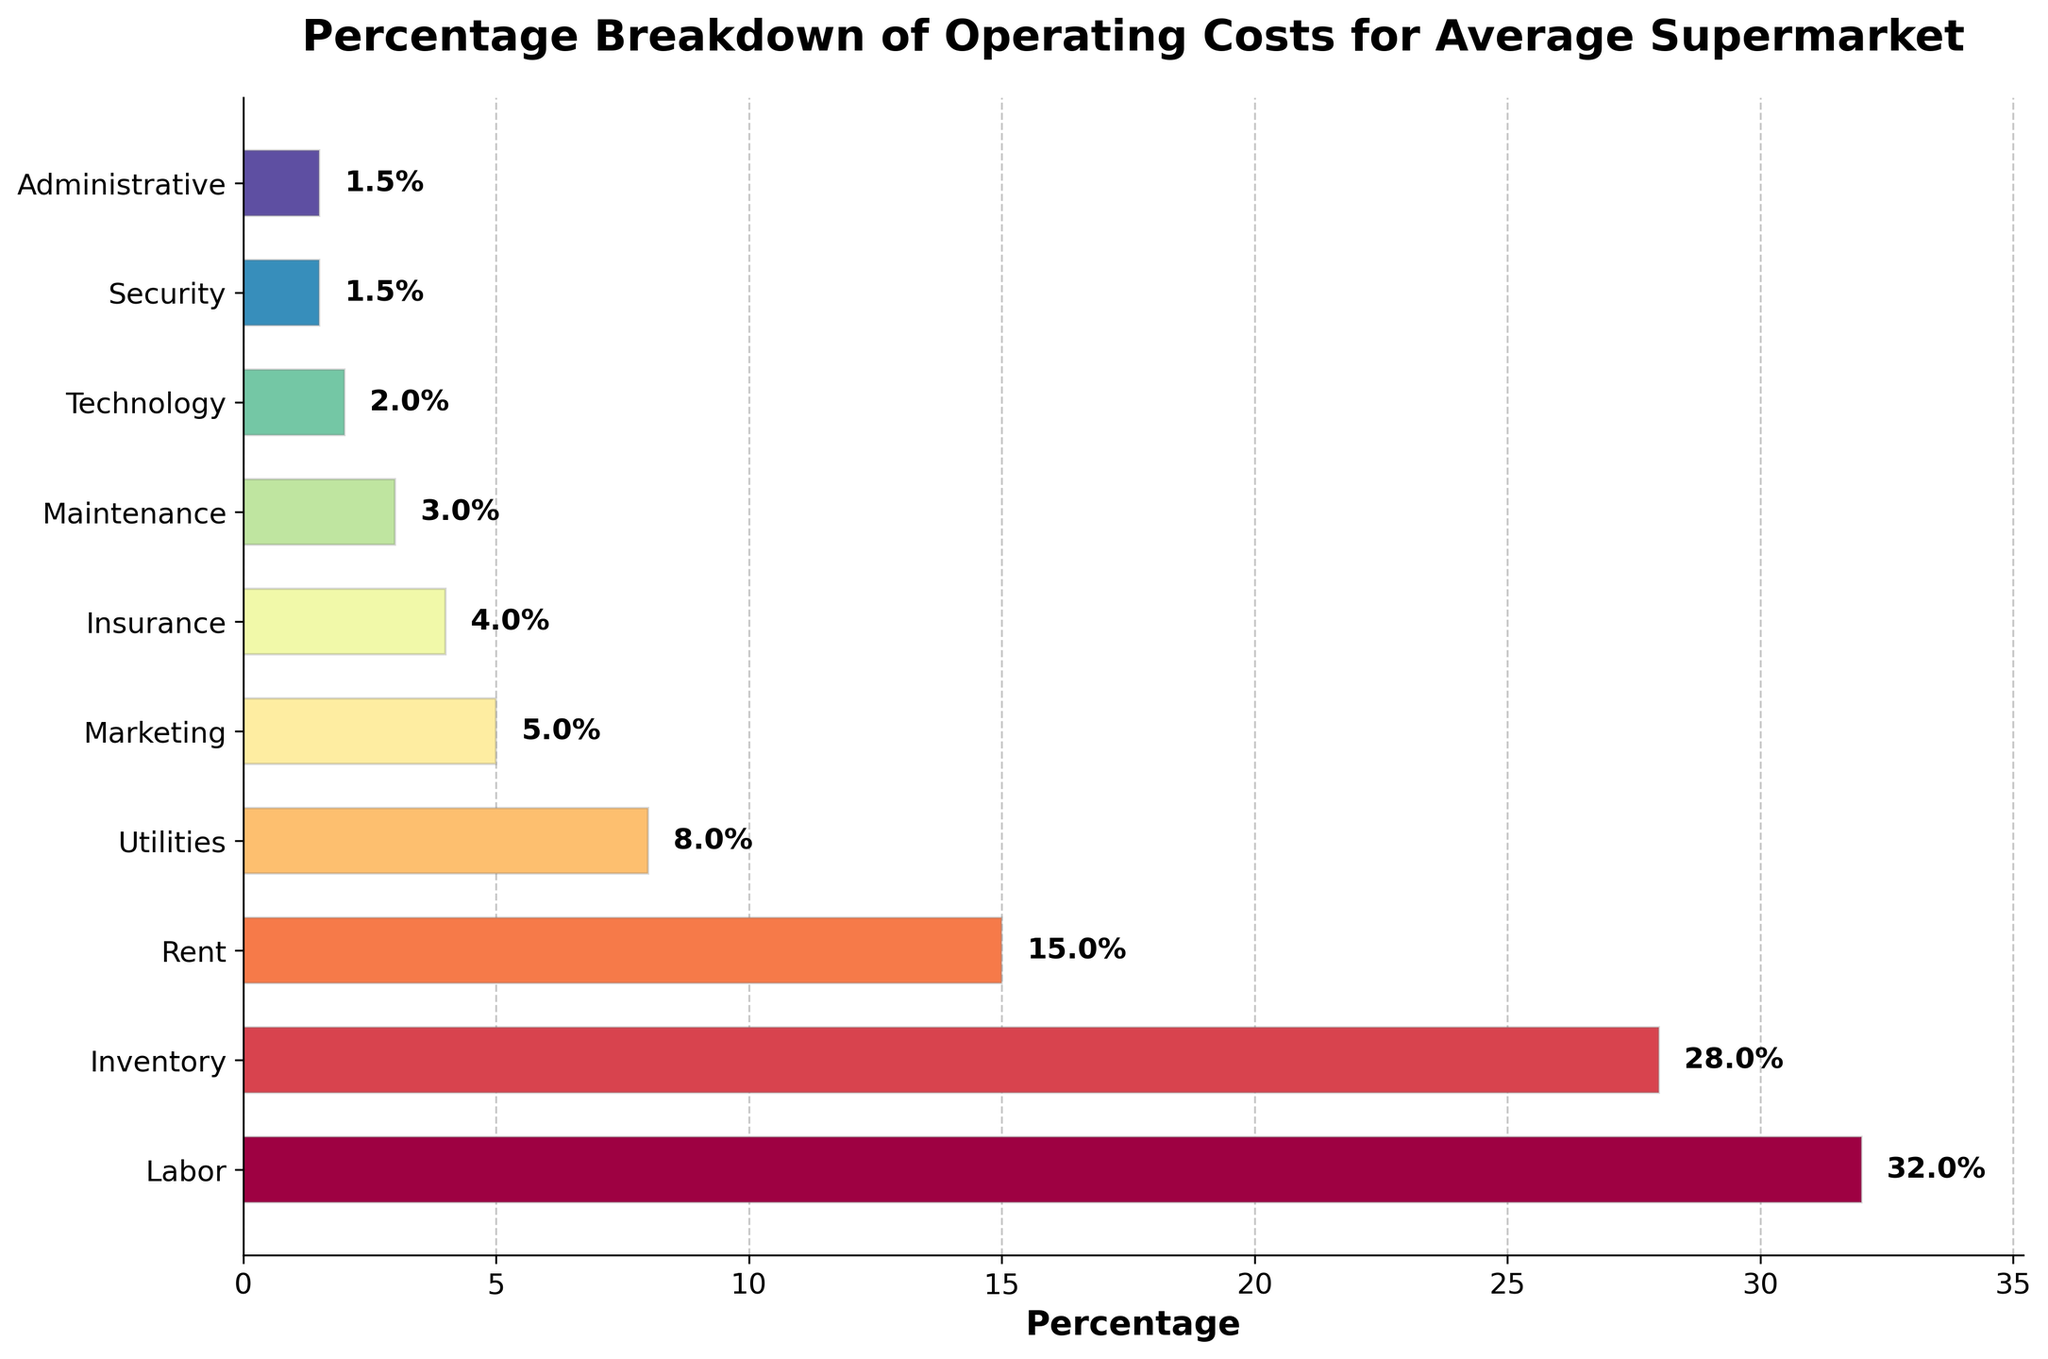What is the largest percentage cost category? The largest percentage cost category has the longest bar in the horizontal bar chart. By looking at the figure, the "Labor" bar is the longest.
Answer: Labor How much more is spent on labor compared to rent? Locate the bars for "Labor" and "Rent." The percentage for "Labor" is 32%, and for "Rent" it is 15%. Subtract Rent from Labor to find the difference: 32% - 15% = 17%.
Answer: 17% Which category has the smallest percentage? The category with the smallest bar will have the smallest percentage. The "Security" and "Administrative" categories both have the smallest percentage, 1.5%.
Answer: Security and Administrative What is the combined percentage of Inventory and Marketing costs? Find the bars for "Inventory" and "Marketing." The percentage for Inventory is 28% and for Marketing is 5%. Add these two percentages together: 28% + 5% = 33%.
Answer: 33% How does the percentage of Maintenance compare to Technology? Identify the bars for "Maintenance" and "Technology." Maintenance is 3%, and Technology is 2%. Maintenance is 1% higher than Technology.
Answer: Maintenance is 1% higher If the total operating costs for an average supermarket are $1,000,000, how much of this is spent on Utilities? Utilities make up 8% of the total operating costs. To find the dollar amount, calculate 8% of $1,000,000: (8 / 100) * $1,000,000 = $80,000.
Answer: $80,000 What is the sum of all percentages excluding the three smallest categories? The three smallest categories are Security (1.5%), Administrative (1.5%), and Technology (2%). Add their percentages: 1.5% + 1.5% + 2% = 5%. Subtract this sum from 100%: 100% - 5% = 95%.
Answer: 95% Which categories contribute more than 20% to the overall operating costs? Categories with bar lengths representing more than 20% are Labor (32%) and Inventory (28%).
Answer: Labor and Inventory What percentage of costs is attributed to non-operational categories like Marketing, Insurance, and Security? Sum the percentages of Marketing (5%), Insurance (4%), and Security (1.5%): 5% + 4% + 1.5% = 10.5%.
Answer: 10.5% By how much does the total percentage of Inventory, Rent, and Utilities exceed the percentage for Labor? Sum the percentages of Inventory (28%), Rent (15%), and Utilities (8%): 28% + 15% + 8% = 51%. Subtract the percentage of Labor (32%): 51% - 32% = 19%.
Answer: 19% 